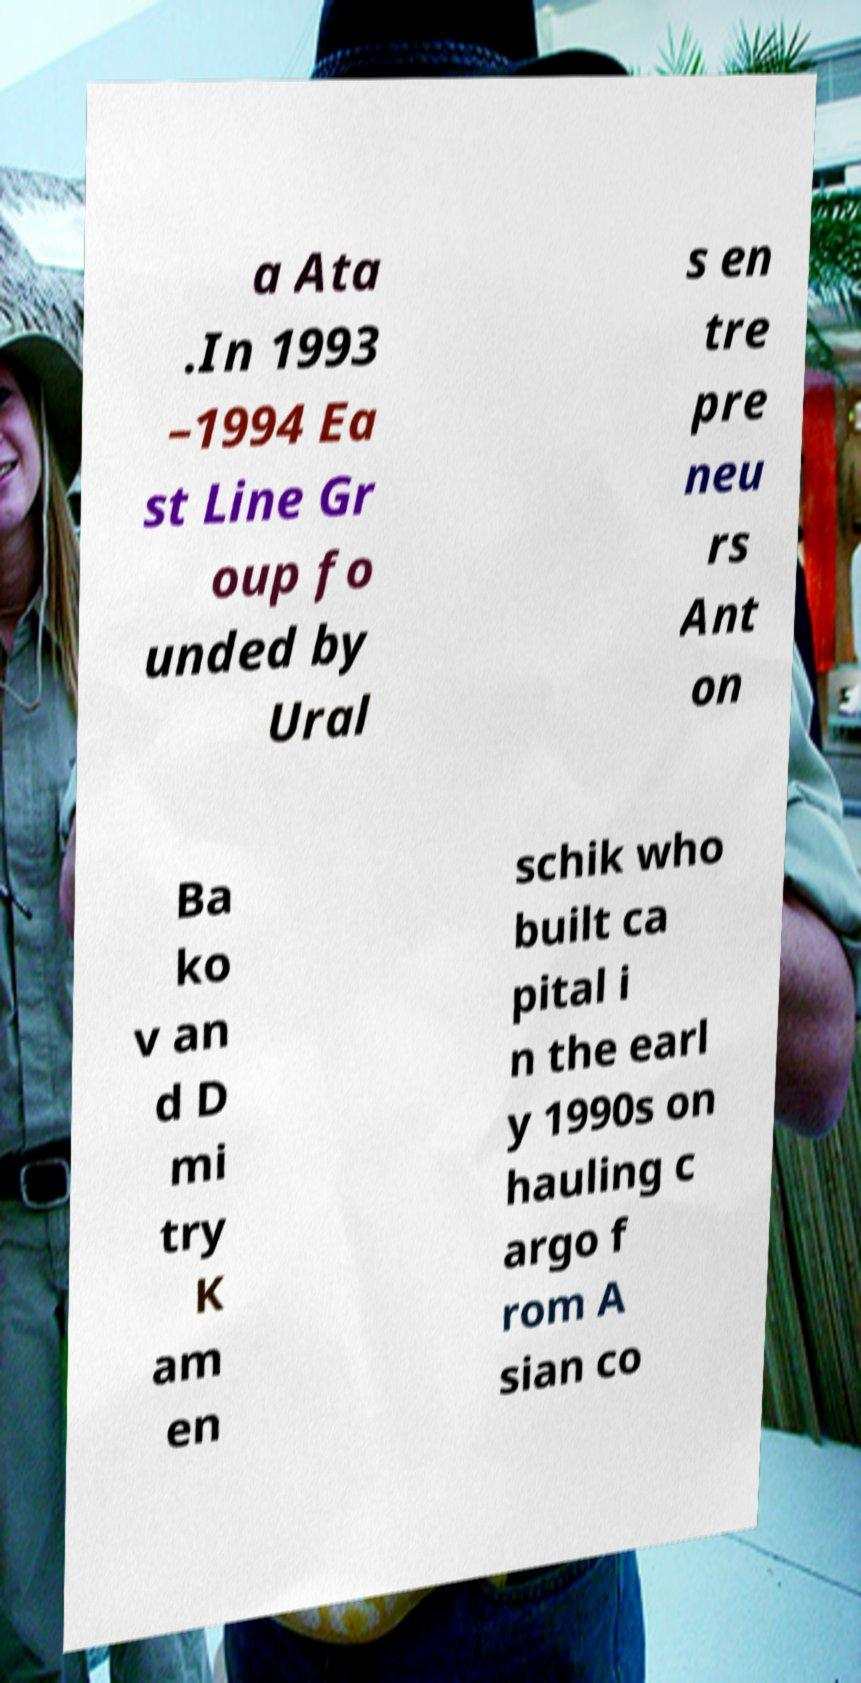There's text embedded in this image that I need extracted. Can you transcribe it verbatim? a Ata .In 1993 –1994 Ea st Line Gr oup fo unded by Ural s en tre pre neu rs Ant on Ba ko v an d D mi try K am en schik who built ca pital i n the earl y 1990s on hauling c argo f rom A sian co 